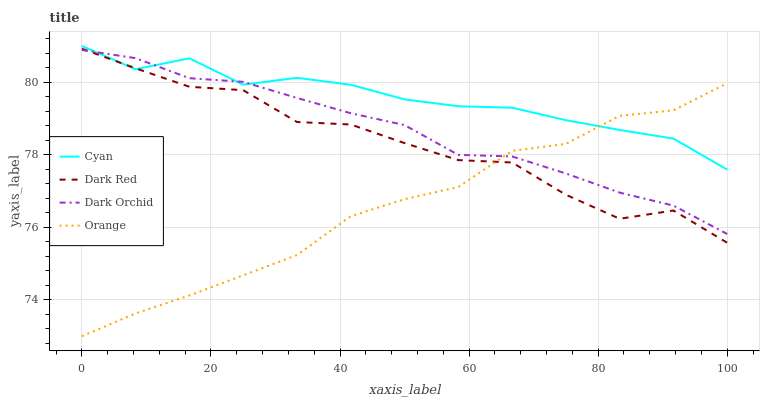Does Orange have the minimum area under the curve?
Answer yes or no. Yes. Does Cyan have the maximum area under the curve?
Answer yes or no. Yes. Does Dark Orchid have the minimum area under the curve?
Answer yes or no. No. Does Dark Orchid have the maximum area under the curve?
Answer yes or no. No. Is Dark Orchid the smoothest?
Answer yes or no. Yes. Is Dark Red the roughest?
Answer yes or no. Yes. Is Cyan the smoothest?
Answer yes or no. No. Is Cyan the roughest?
Answer yes or no. No. Does Orange have the lowest value?
Answer yes or no. Yes. Does Dark Orchid have the lowest value?
Answer yes or no. No. Does Cyan have the highest value?
Answer yes or no. Yes. Does Dark Orchid have the highest value?
Answer yes or no. No. Does Dark Orchid intersect Cyan?
Answer yes or no. Yes. Is Dark Orchid less than Cyan?
Answer yes or no. No. Is Dark Orchid greater than Cyan?
Answer yes or no. No. 